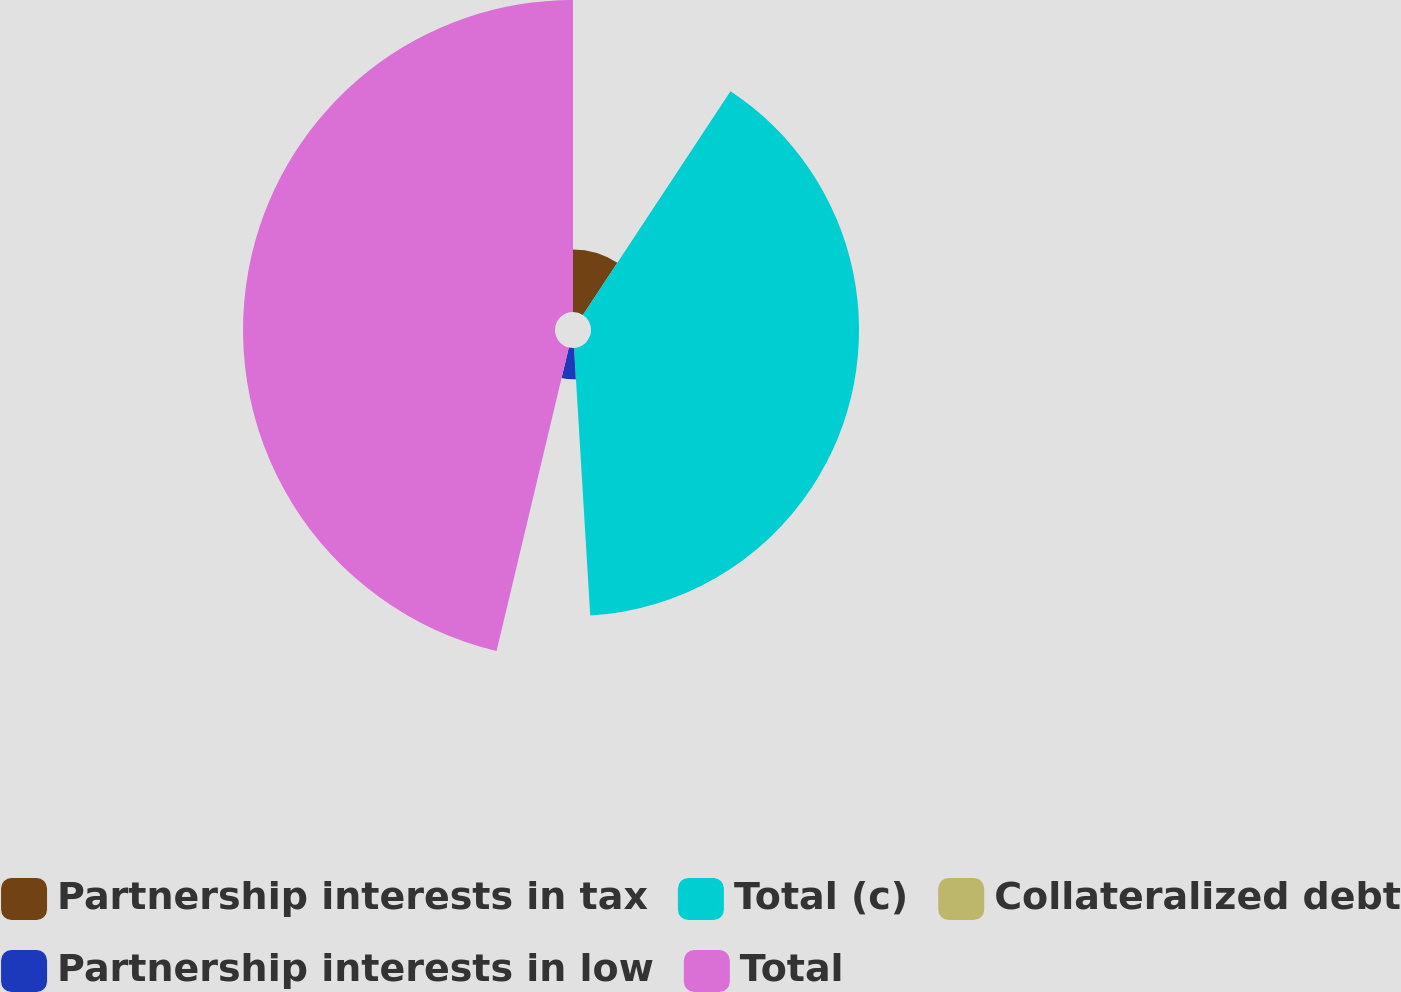Convert chart. <chart><loc_0><loc_0><loc_500><loc_500><pie_chart><fcel>Partnership interests in tax<fcel>Total (c)<fcel>Collateralized debt<fcel>Partnership interests in low<fcel>Total<nl><fcel>9.28%<fcel>39.76%<fcel>0.03%<fcel>4.65%<fcel>46.28%<nl></chart> 